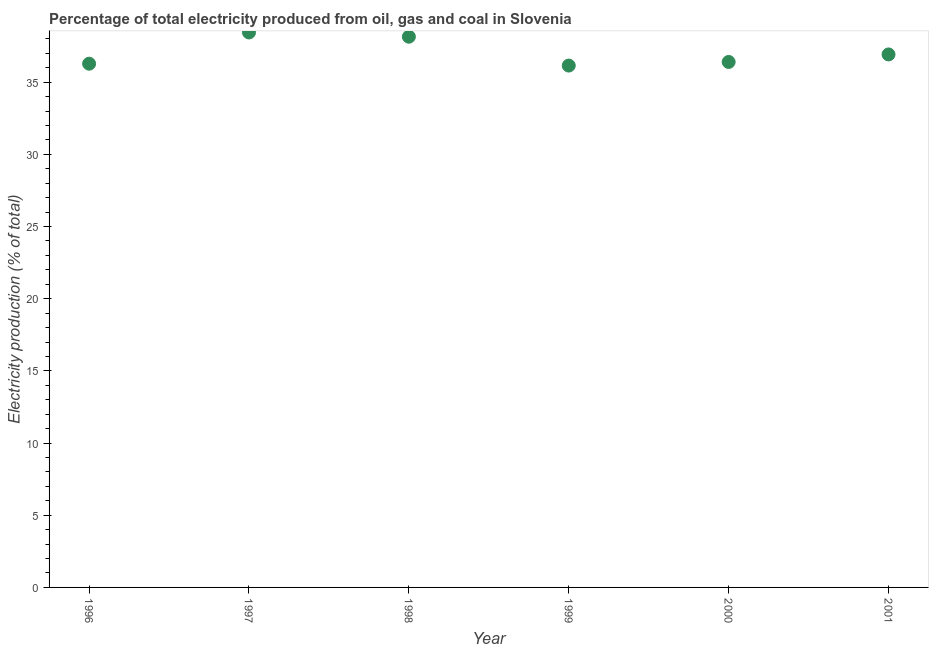What is the electricity production in 1997?
Provide a short and direct response. 38.44. Across all years, what is the maximum electricity production?
Your answer should be very brief. 38.44. Across all years, what is the minimum electricity production?
Give a very brief answer. 36.15. What is the sum of the electricity production?
Offer a terse response. 222.34. What is the difference between the electricity production in 1996 and 2000?
Ensure brevity in your answer.  -0.12. What is the average electricity production per year?
Offer a very short reply. 37.06. What is the median electricity production?
Your answer should be very brief. 36.66. What is the ratio of the electricity production in 1999 to that in 2000?
Your answer should be very brief. 0.99. What is the difference between the highest and the second highest electricity production?
Ensure brevity in your answer.  0.29. What is the difference between the highest and the lowest electricity production?
Provide a succinct answer. 2.29. Does the electricity production monotonically increase over the years?
Your answer should be very brief. No. How many years are there in the graph?
Ensure brevity in your answer.  6. Are the values on the major ticks of Y-axis written in scientific E-notation?
Your response must be concise. No. Does the graph contain any zero values?
Provide a succinct answer. No. Does the graph contain grids?
Offer a terse response. No. What is the title of the graph?
Keep it short and to the point. Percentage of total electricity produced from oil, gas and coal in Slovenia. What is the label or title of the X-axis?
Give a very brief answer. Year. What is the label or title of the Y-axis?
Your answer should be compact. Electricity production (% of total). What is the Electricity production (% of total) in 1996?
Offer a very short reply. 36.28. What is the Electricity production (% of total) in 1997?
Make the answer very short. 38.44. What is the Electricity production (% of total) in 1998?
Your response must be concise. 38.15. What is the Electricity production (% of total) in 1999?
Keep it short and to the point. 36.15. What is the Electricity production (% of total) in 2000?
Your answer should be very brief. 36.4. What is the Electricity production (% of total) in 2001?
Your answer should be very brief. 36.92. What is the difference between the Electricity production (% of total) in 1996 and 1997?
Keep it short and to the point. -2.16. What is the difference between the Electricity production (% of total) in 1996 and 1998?
Offer a terse response. -1.87. What is the difference between the Electricity production (% of total) in 1996 and 1999?
Provide a succinct answer. 0.13. What is the difference between the Electricity production (% of total) in 1996 and 2000?
Make the answer very short. -0.12. What is the difference between the Electricity production (% of total) in 1996 and 2001?
Provide a succinct answer. -0.64. What is the difference between the Electricity production (% of total) in 1997 and 1998?
Offer a very short reply. 0.29. What is the difference between the Electricity production (% of total) in 1997 and 1999?
Offer a very short reply. 2.29. What is the difference between the Electricity production (% of total) in 1997 and 2000?
Provide a succinct answer. 2.04. What is the difference between the Electricity production (% of total) in 1997 and 2001?
Give a very brief answer. 1.52. What is the difference between the Electricity production (% of total) in 1998 and 1999?
Offer a very short reply. 2. What is the difference between the Electricity production (% of total) in 1998 and 2000?
Your response must be concise. 1.75. What is the difference between the Electricity production (% of total) in 1998 and 2001?
Provide a short and direct response. 1.23. What is the difference between the Electricity production (% of total) in 1999 and 2000?
Provide a succinct answer. -0.25. What is the difference between the Electricity production (% of total) in 1999 and 2001?
Offer a very short reply. -0.77. What is the difference between the Electricity production (% of total) in 2000 and 2001?
Offer a terse response. -0.52. What is the ratio of the Electricity production (% of total) in 1996 to that in 1997?
Your response must be concise. 0.94. What is the ratio of the Electricity production (% of total) in 1996 to that in 1998?
Your response must be concise. 0.95. What is the ratio of the Electricity production (% of total) in 1996 to that in 2000?
Your answer should be very brief. 1. What is the ratio of the Electricity production (% of total) in 1997 to that in 1998?
Keep it short and to the point. 1.01. What is the ratio of the Electricity production (% of total) in 1997 to that in 1999?
Offer a terse response. 1.06. What is the ratio of the Electricity production (% of total) in 1997 to that in 2000?
Offer a very short reply. 1.06. What is the ratio of the Electricity production (% of total) in 1997 to that in 2001?
Provide a short and direct response. 1.04. What is the ratio of the Electricity production (% of total) in 1998 to that in 1999?
Offer a terse response. 1.05. What is the ratio of the Electricity production (% of total) in 1998 to that in 2000?
Keep it short and to the point. 1.05. What is the ratio of the Electricity production (% of total) in 1998 to that in 2001?
Offer a very short reply. 1.03. What is the ratio of the Electricity production (% of total) in 1999 to that in 2000?
Provide a short and direct response. 0.99. What is the ratio of the Electricity production (% of total) in 1999 to that in 2001?
Your response must be concise. 0.98. 